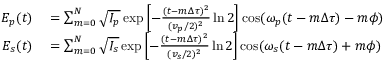Convert formula to latex. <formula><loc_0><loc_0><loc_500><loc_500>\begin{array} { r l } { E _ { p } ( t ) } & = \sum _ { m = 0 } ^ { N } { \sqrt { I _ { p } } \exp \left [ - \frac { ( t - m \Delta \tau ) ^ { 2 } } { ( v _ { p } / 2 ) ^ { 2 } } \ln 2 \right ] \cos ( \omega _ { p } ( t - m \Delta \tau ) - m \phi ) } } \\ { E _ { s } ( t ) } & = \sum _ { m = 0 } ^ { N } { \sqrt { I _ { s } } \exp \left [ - \frac { ( t - m \Delta \tau ) ^ { 2 } } { ( v _ { s } / 2 ) ^ { 2 } } \ln 2 \right ] \cos ( \omega _ { s } ( t - m \Delta \tau ) + m \phi ) } } \end{array}</formula> 